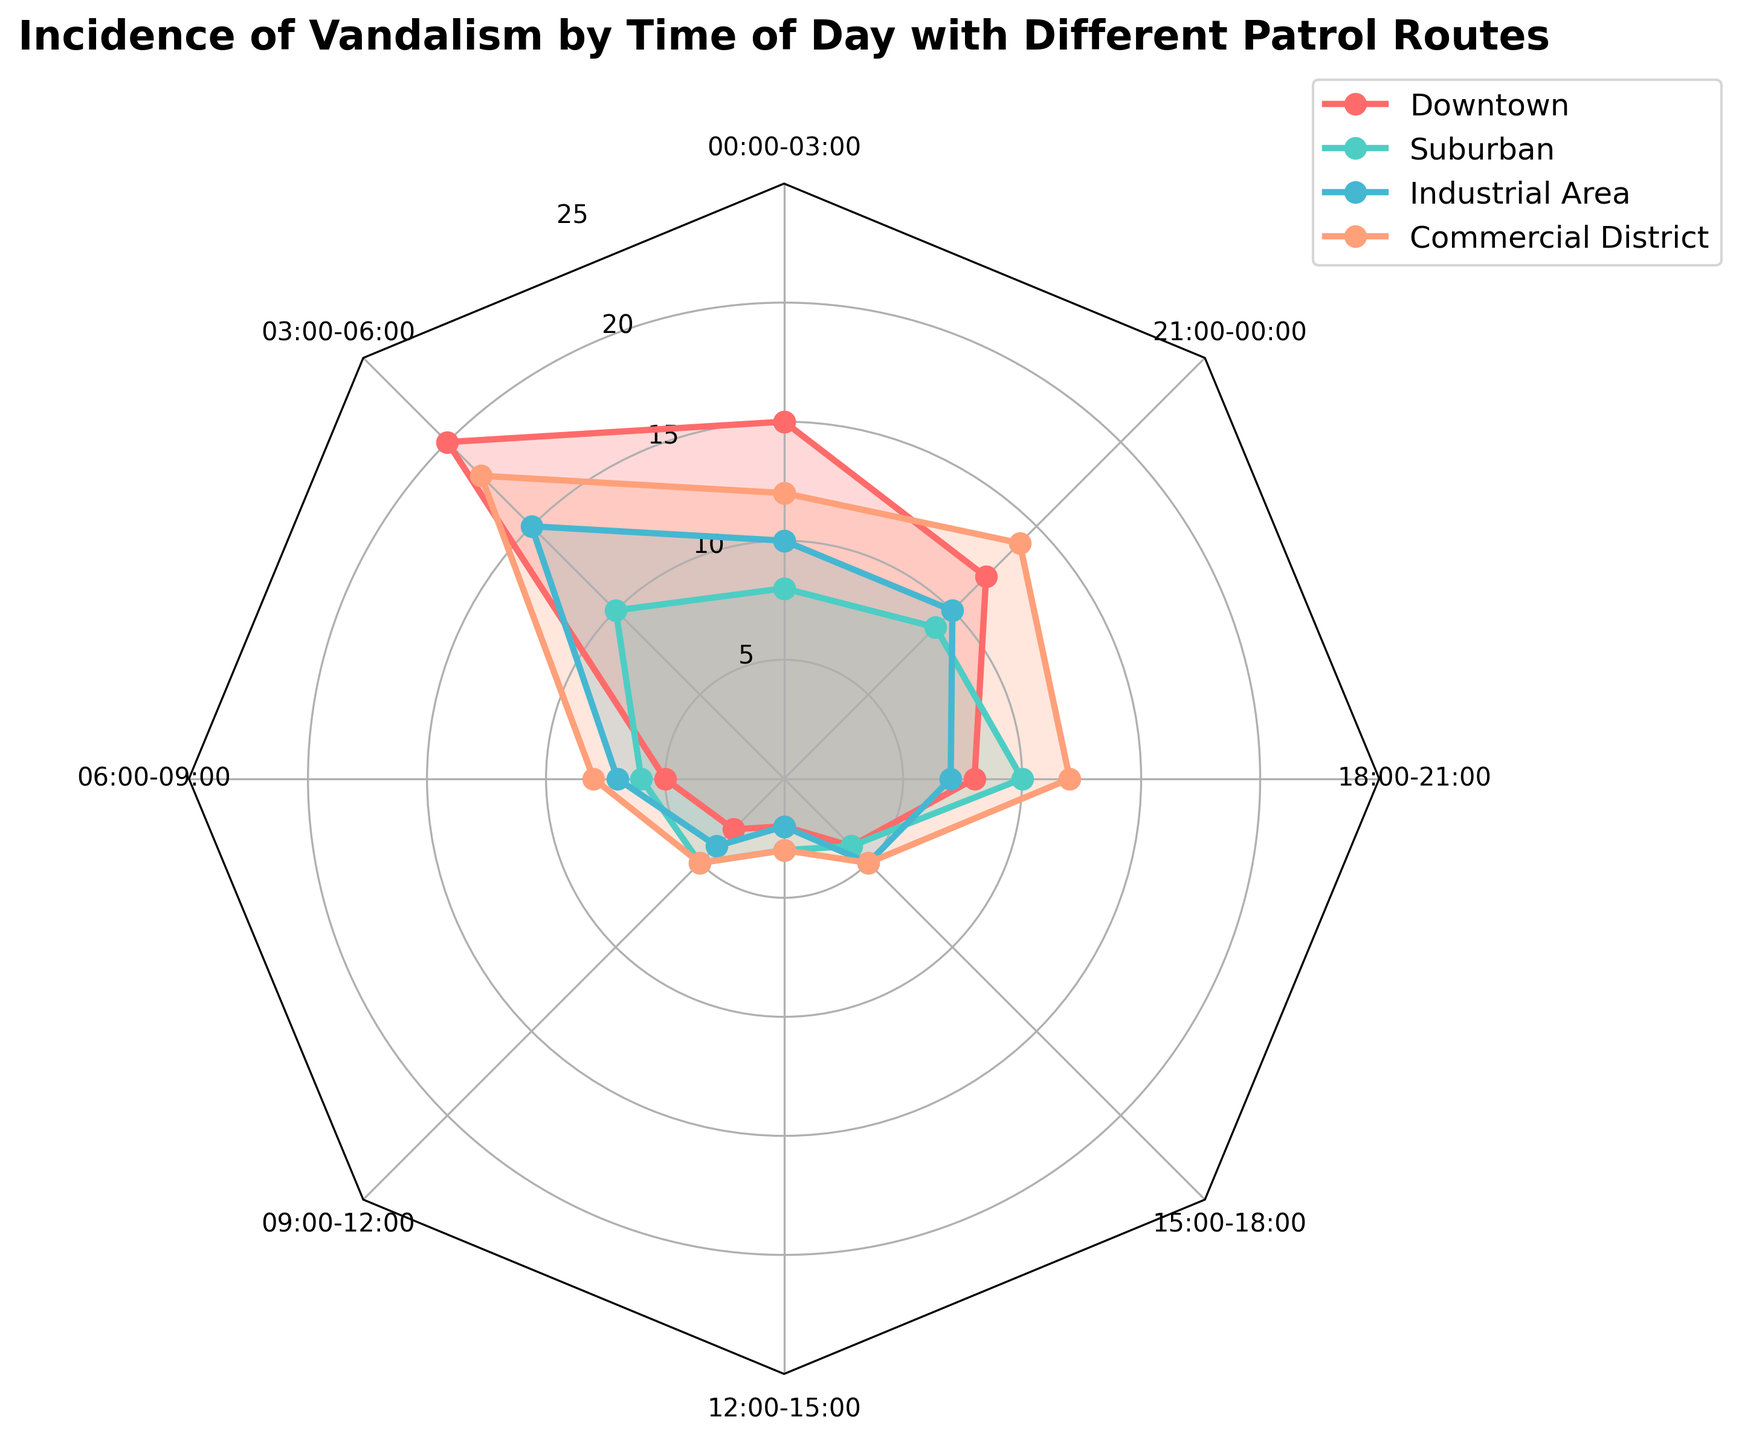what are the patrol routes shown in the radar chart? The radar chart uses different colors to represent each patrol route. Looking at the legend, we can see the names of the patrol routes: Downtown, Suburban, Industrial Area, and Commercial District.
Answer: Downtown, Suburban, Industrial Area, Commercial District At what time of day does the Downtown route experience the highest incidence of vandalism? By looking at the segments of the radar chart for the Downtown route, it's clear the highest incidence of vandalism occurs in the 03:00-06:00 time slot, where the value reaches 20.
Answer: 03:00-06:00 How does the incidence of vandalism during 00:00-03:00 compare between the Suburban and Industrial Area routes? We see that the radar chart shows the incidence for Suburban as 8 and for Industrial Area as 10 during the 00:00-03:00 time slot. Therefore, the Industrial Area has a higher incidence.
Answer: Industrial Area has 2 more incidents than Suburban What is the average incidence of vandalism for the Commercial District across all time slots? By summing the values for the Commercial District (12, 18, 8, 5, 3, 5, 12, 14) and then dividing by the number of time slots (8), we get the average. The total is 77, and the average is 77/8 = 9.625.
Answer: 9.625 Which time slot has the lowest incidence of vandalism in the Downtown route? The radar chart shows the values for the Downtown route. The lowest incidence is found at the 12:00-15:00 time slot, where the value is 2.
Answer: 12:00-15:00 During which time slots do all four routes experience incidences of vandalism greater than or equal to 5? By observing the radar chart, we see that for the 06:00-09:00, 18:00-21:00, and 21:00-00:00 time slots, all routes have incidences of vandalism greater than or equal to 5.
Answer: 06:00-09:00, 18:00-21:00, 21:00-00:00 Which time slot shows the greatest spread in the incidence of vandalism among the different routes? The greatest spread can be identified by the maximum range between the highest and lowest values in each time slot. The 03:00-06:00 time slot for the Downtown (20) and Suburban (10) routes shows the largest difference (20 - 10 = 10).
Answer: 03:00-06:00 How does the incidence of vandalism in the 03:00-06:00 slot for the Commercial District compare to that for the Downtown route? The radar chart shows 18 incidents for the Commercial District and 20 for Downtown in the 03:00-06:00 slot. Therefore, the Downtown route has a higher incidence by 2.
Answer: Downtown is 2 incidents higher than Commercial District 